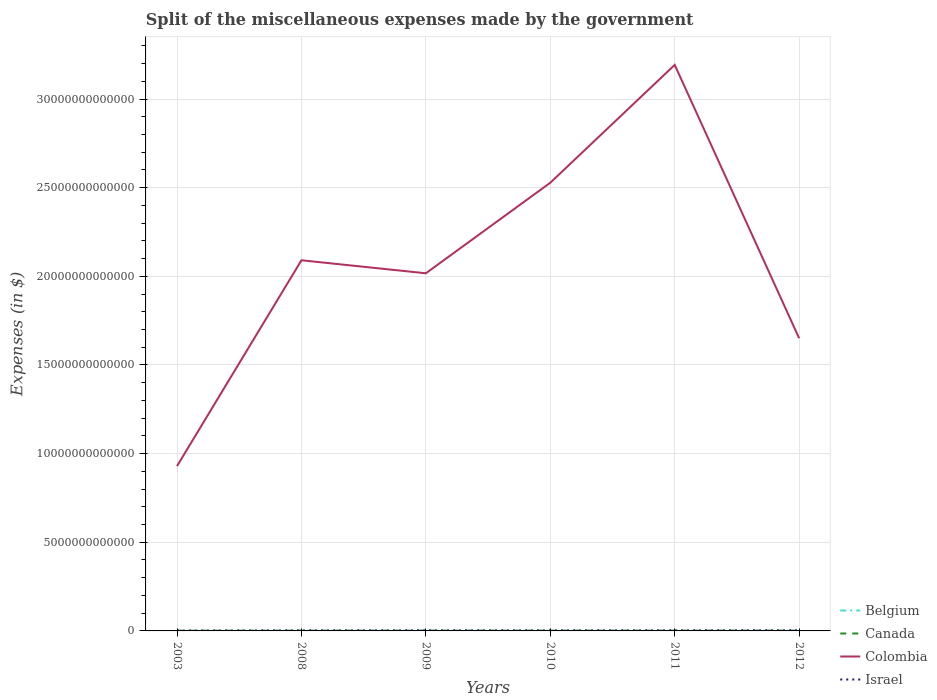How many different coloured lines are there?
Provide a succinct answer. 4. Across all years, what is the maximum miscellaneous expenses made by the government in Colombia?
Make the answer very short. 9.30e+12. What is the total miscellaneous expenses made by the government in Colombia in the graph?
Offer a terse response. -4.37e+12. What is the difference between the highest and the second highest miscellaneous expenses made by the government in Colombia?
Provide a short and direct response. 2.26e+13. What is the difference between two consecutive major ticks on the Y-axis?
Your answer should be compact. 5.00e+12. How are the legend labels stacked?
Make the answer very short. Vertical. What is the title of the graph?
Your answer should be compact. Split of the miscellaneous expenses made by the government. What is the label or title of the X-axis?
Keep it short and to the point. Years. What is the label or title of the Y-axis?
Give a very brief answer. Expenses (in $). What is the Expenses (in $) of Belgium in 2003?
Make the answer very short. 3.96e+09. What is the Expenses (in $) of Canada in 2003?
Provide a succinct answer. 1.14e+1. What is the Expenses (in $) in Colombia in 2003?
Make the answer very short. 9.30e+12. What is the Expenses (in $) in Israel in 2003?
Keep it short and to the point. 1.77e+1. What is the Expenses (in $) of Belgium in 2008?
Provide a short and direct response. 3.34e+09. What is the Expenses (in $) in Canada in 2008?
Your answer should be very brief. 1.42e+1. What is the Expenses (in $) of Colombia in 2008?
Offer a terse response. 2.09e+13. What is the Expenses (in $) in Israel in 2008?
Offer a very short reply. 2.70e+1. What is the Expenses (in $) in Belgium in 2009?
Give a very brief answer. 4.92e+09. What is the Expenses (in $) in Canada in 2009?
Your response must be concise. 1.54e+1. What is the Expenses (in $) of Colombia in 2009?
Give a very brief answer. 2.02e+13. What is the Expenses (in $) of Israel in 2009?
Your answer should be very brief. 2.99e+1. What is the Expenses (in $) in Belgium in 2010?
Your response must be concise. 3.68e+09. What is the Expenses (in $) of Canada in 2010?
Give a very brief answer. 1.59e+1. What is the Expenses (in $) in Colombia in 2010?
Keep it short and to the point. 2.53e+13. What is the Expenses (in $) of Israel in 2010?
Your response must be concise. 2.93e+1. What is the Expenses (in $) in Belgium in 2011?
Offer a very short reply. 7.59e+08. What is the Expenses (in $) in Canada in 2011?
Ensure brevity in your answer.  1.62e+1. What is the Expenses (in $) of Colombia in 2011?
Offer a terse response. 3.19e+13. What is the Expenses (in $) of Israel in 2011?
Your response must be concise. 2.95e+1. What is the Expenses (in $) in Belgium in 2012?
Offer a very short reply. 7.77e+08. What is the Expenses (in $) in Canada in 2012?
Make the answer very short. 1.66e+1. What is the Expenses (in $) in Colombia in 2012?
Your answer should be very brief. 1.65e+13. What is the Expenses (in $) in Israel in 2012?
Make the answer very short. 3.33e+1. Across all years, what is the maximum Expenses (in $) of Belgium?
Your answer should be compact. 4.92e+09. Across all years, what is the maximum Expenses (in $) in Canada?
Offer a very short reply. 1.66e+1. Across all years, what is the maximum Expenses (in $) in Colombia?
Ensure brevity in your answer.  3.19e+13. Across all years, what is the maximum Expenses (in $) of Israel?
Your response must be concise. 3.33e+1. Across all years, what is the minimum Expenses (in $) in Belgium?
Provide a succinct answer. 7.59e+08. Across all years, what is the minimum Expenses (in $) of Canada?
Offer a terse response. 1.14e+1. Across all years, what is the minimum Expenses (in $) in Colombia?
Give a very brief answer. 9.30e+12. Across all years, what is the minimum Expenses (in $) in Israel?
Offer a terse response. 1.77e+1. What is the total Expenses (in $) in Belgium in the graph?
Provide a short and direct response. 1.74e+1. What is the total Expenses (in $) in Canada in the graph?
Make the answer very short. 8.98e+1. What is the total Expenses (in $) of Colombia in the graph?
Make the answer very short. 1.24e+14. What is the total Expenses (in $) in Israel in the graph?
Your response must be concise. 1.67e+11. What is the difference between the Expenses (in $) in Belgium in 2003 and that in 2008?
Offer a terse response. 6.13e+08. What is the difference between the Expenses (in $) of Canada in 2003 and that in 2008?
Make the answer very short. -2.78e+09. What is the difference between the Expenses (in $) of Colombia in 2003 and that in 2008?
Give a very brief answer. -1.16e+13. What is the difference between the Expenses (in $) in Israel in 2003 and that in 2008?
Provide a short and direct response. -9.31e+09. What is the difference between the Expenses (in $) of Belgium in 2003 and that in 2009?
Keep it short and to the point. -9.66e+08. What is the difference between the Expenses (in $) of Canada in 2003 and that in 2009?
Keep it short and to the point. -3.97e+09. What is the difference between the Expenses (in $) of Colombia in 2003 and that in 2009?
Provide a succinct answer. -1.09e+13. What is the difference between the Expenses (in $) of Israel in 2003 and that in 2009?
Provide a succinct answer. -1.22e+1. What is the difference between the Expenses (in $) of Belgium in 2003 and that in 2010?
Your answer should be very brief. 2.74e+08. What is the difference between the Expenses (in $) of Canada in 2003 and that in 2010?
Offer a terse response. -4.48e+09. What is the difference between the Expenses (in $) of Colombia in 2003 and that in 2010?
Keep it short and to the point. -1.60e+13. What is the difference between the Expenses (in $) in Israel in 2003 and that in 2010?
Make the answer very short. -1.16e+1. What is the difference between the Expenses (in $) in Belgium in 2003 and that in 2011?
Provide a short and direct response. 3.20e+09. What is the difference between the Expenses (in $) in Canada in 2003 and that in 2011?
Give a very brief answer. -4.76e+09. What is the difference between the Expenses (in $) in Colombia in 2003 and that in 2011?
Keep it short and to the point. -2.26e+13. What is the difference between the Expenses (in $) of Israel in 2003 and that in 2011?
Make the answer very short. -1.18e+1. What is the difference between the Expenses (in $) of Belgium in 2003 and that in 2012?
Your response must be concise. 3.18e+09. What is the difference between the Expenses (in $) in Canada in 2003 and that in 2012?
Your answer should be compact. -5.13e+09. What is the difference between the Expenses (in $) of Colombia in 2003 and that in 2012?
Offer a terse response. -7.21e+12. What is the difference between the Expenses (in $) in Israel in 2003 and that in 2012?
Make the answer very short. -1.56e+1. What is the difference between the Expenses (in $) in Belgium in 2008 and that in 2009?
Offer a very short reply. -1.58e+09. What is the difference between the Expenses (in $) of Canada in 2008 and that in 2009?
Your response must be concise. -1.19e+09. What is the difference between the Expenses (in $) in Colombia in 2008 and that in 2009?
Your answer should be compact. 7.33e+11. What is the difference between the Expenses (in $) of Israel in 2008 and that in 2009?
Provide a short and direct response. -2.87e+09. What is the difference between the Expenses (in $) of Belgium in 2008 and that in 2010?
Make the answer very short. -3.39e+08. What is the difference between the Expenses (in $) of Canada in 2008 and that in 2010?
Provide a succinct answer. -1.70e+09. What is the difference between the Expenses (in $) in Colombia in 2008 and that in 2010?
Ensure brevity in your answer.  -4.37e+12. What is the difference between the Expenses (in $) of Israel in 2008 and that in 2010?
Your answer should be very brief. -2.29e+09. What is the difference between the Expenses (in $) of Belgium in 2008 and that in 2011?
Make the answer very short. 2.58e+09. What is the difference between the Expenses (in $) of Canada in 2008 and that in 2011?
Your answer should be very brief. -1.98e+09. What is the difference between the Expenses (in $) in Colombia in 2008 and that in 2011?
Your answer should be compact. -1.10e+13. What is the difference between the Expenses (in $) of Israel in 2008 and that in 2011?
Provide a short and direct response. -2.46e+09. What is the difference between the Expenses (in $) of Belgium in 2008 and that in 2012?
Offer a terse response. 2.57e+09. What is the difference between the Expenses (in $) in Canada in 2008 and that in 2012?
Provide a short and direct response. -2.35e+09. What is the difference between the Expenses (in $) in Colombia in 2008 and that in 2012?
Offer a terse response. 4.40e+12. What is the difference between the Expenses (in $) in Israel in 2008 and that in 2012?
Provide a short and direct response. -6.25e+09. What is the difference between the Expenses (in $) in Belgium in 2009 and that in 2010?
Ensure brevity in your answer.  1.24e+09. What is the difference between the Expenses (in $) in Canada in 2009 and that in 2010?
Give a very brief answer. -5.11e+08. What is the difference between the Expenses (in $) of Colombia in 2009 and that in 2010?
Provide a short and direct response. -5.11e+12. What is the difference between the Expenses (in $) in Israel in 2009 and that in 2010?
Your answer should be compact. 5.78e+08. What is the difference between the Expenses (in $) of Belgium in 2009 and that in 2011?
Give a very brief answer. 4.16e+09. What is the difference between the Expenses (in $) of Canada in 2009 and that in 2011?
Your response must be concise. -7.90e+08. What is the difference between the Expenses (in $) of Colombia in 2009 and that in 2011?
Offer a terse response. -1.18e+13. What is the difference between the Expenses (in $) of Israel in 2009 and that in 2011?
Keep it short and to the point. 4.09e+08. What is the difference between the Expenses (in $) in Belgium in 2009 and that in 2012?
Provide a succinct answer. 4.15e+09. What is the difference between the Expenses (in $) of Canada in 2009 and that in 2012?
Offer a very short reply. -1.16e+09. What is the difference between the Expenses (in $) of Colombia in 2009 and that in 2012?
Provide a succinct answer. 3.66e+12. What is the difference between the Expenses (in $) of Israel in 2009 and that in 2012?
Your answer should be very brief. -3.37e+09. What is the difference between the Expenses (in $) in Belgium in 2010 and that in 2011?
Offer a very short reply. 2.92e+09. What is the difference between the Expenses (in $) in Canada in 2010 and that in 2011?
Give a very brief answer. -2.79e+08. What is the difference between the Expenses (in $) of Colombia in 2010 and that in 2011?
Your answer should be very brief. -6.65e+12. What is the difference between the Expenses (in $) in Israel in 2010 and that in 2011?
Provide a short and direct response. -1.70e+08. What is the difference between the Expenses (in $) in Belgium in 2010 and that in 2012?
Offer a terse response. 2.91e+09. What is the difference between the Expenses (in $) of Canada in 2010 and that in 2012?
Give a very brief answer. -6.46e+08. What is the difference between the Expenses (in $) in Colombia in 2010 and that in 2012?
Your answer should be compact. 8.77e+12. What is the difference between the Expenses (in $) in Israel in 2010 and that in 2012?
Give a very brief answer. -3.95e+09. What is the difference between the Expenses (in $) of Belgium in 2011 and that in 2012?
Give a very brief answer. -1.77e+07. What is the difference between the Expenses (in $) of Canada in 2011 and that in 2012?
Provide a succinct answer. -3.67e+08. What is the difference between the Expenses (in $) in Colombia in 2011 and that in 2012?
Give a very brief answer. 1.54e+13. What is the difference between the Expenses (in $) of Israel in 2011 and that in 2012?
Give a very brief answer. -3.78e+09. What is the difference between the Expenses (in $) in Belgium in 2003 and the Expenses (in $) in Canada in 2008?
Give a very brief answer. -1.03e+1. What is the difference between the Expenses (in $) of Belgium in 2003 and the Expenses (in $) of Colombia in 2008?
Your answer should be compact. -2.09e+13. What is the difference between the Expenses (in $) of Belgium in 2003 and the Expenses (in $) of Israel in 2008?
Provide a succinct answer. -2.31e+1. What is the difference between the Expenses (in $) in Canada in 2003 and the Expenses (in $) in Colombia in 2008?
Your answer should be very brief. -2.09e+13. What is the difference between the Expenses (in $) in Canada in 2003 and the Expenses (in $) in Israel in 2008?
Your answer should be compact. -1.56e+1. What is the difference between the Expenses (in $) of Colombia in 2003 and the Expenses (in $) of Israel in 2008?
Your answer should be compact. 9.27e+12. What is the difference between the Expenses (in $) of Belgium in 2003 and the Expenses (in $) of Canada in 2009?
Your response must be concise. -1.15e+1. What is the difference between the Expenses (in $) in Belgium in 2003 and the Expenses (in $) in Colombia in 2009?
Ensure brevity in your answer.  -2.02e+13. What is the difference between the Expenses (in $) of Belgium in 2003 and the Expenses (in $) of Israel in 2009?
Keep it short and to the point. -2.59e+1. What is the difference between the Expenses (in $) in Canada in 2003 and the Expenses (in $) in Colombia in 2009?
Offer a very short reply. -2.02e+13. What is the difference between the Expenses (in $) in Canada in 2003 and the Expenses (in $) in Israel in 2009?
Ensure brevity in your answer.  -1.84e+1. What is the difference between the Expenses (in $) in Colombia in 2003 and the Expenses (in $) in Israel in 2009?
Offer a terse response. 9.27e+12. What is the difference between the Expenses (in $) in Belgium in 2003 and the Expenses (in $) in Canada in 2010?
Your answer should be compact. -1.20e+1. What is the difference between the Expenses (in $) in Belgium in 2003 and the Expenses (in $) in Colombia in 2010?
Keep it short and to the point. -2.53e+13. What is the difference between the Expenses (in $) of Belgium in 2003 and the Expenses (in $) of Israel in 2010?
Provide a succinct answer. -2.54e+1. What is the difference between the Expenses (in $) in Canada in 2003 and the Expenses (in $) in Colombia in 2010?
Keep it short and to the point. -2.53e+13. What is the difference between the Expenses (in $) of Canada in 2003 and the Expenses (in $) of Israel in 2010?
Provide a succinct answer. -1.79e+1. What is the difference between the Expenses (in $) of Colombia in 2003 and the Expenses (in $) of Israel in 2010?
Provide a succinct answer. 9.27e+12. What is the difference between the Expenses (in $) in Belgium in 2003 and the Expenses (in $) in Canada in 2011?
Your response must be concise. -1.22e+1. What is the difference between the Expenses (in $) of Belgium in 2003 and the Expenses (in $) of Colombia in 2011?
Ensure brevity in your answer.  -3.19e+13. What is the difference between the Expenses (in $) of Belgium in 2003 and the Expenses (in $) of Israel in 2011?
Ensure brevity in your answer.  -2.55e+1. What is the difference between the Expenses (in $) of Canada in 2003 and the Expenses (in $) of Colombia in 2011?
Your answer should be very brief. -3.19e+13. What is the difference between the Expenses (in $) of Canada in 2003 and the Expenses (in $) of Israel in 2011?
Keep it short and to the point. -1.80e+1. What is the difference between the Expenses (in $) in Colombia in 2003 and the Expenses (in $) in Israel in 2011?
Give a very brief answer. 9.27e+12. What is the difference between the Expenses (in $) in Belgium in 2003 and the Expenses (in $) in Canada in 2012?
Give a very brief answer. -1.26e+1. What is the difference between the Expenses (in $) in Belgium in 2003 and the Expenses (in $) in Colombia in 2012?
Offer a terse response. -1.65e+13. What is the difference between the Expenses (in $) in Belgium in 2003 and the Expenses (in $) in Israel in 2012?
Offer a terse response. -2.93e+1. What is the difference between the Expenses (in $) in Canada in 2003 and the Expenses (in $) in Colombia in 2012?
Make the answer very short. -1.65e+13. What is the difference between the Expenses (in $) of Canada in 2003 and the Expenses (in $) of Israel in 2012?
Keep it short and to the point. -2.18e+1. What is the difference between the Expenses (in $) in Colombia in 2003 and the Expenses (in $) in Israel in 2012?
Keep it short and to the point. 9.26e+12. What is the difference between the Expenses (in $) of Belgium in 2008 and the Expenses (in $) of Canada in 2009?
Provide a succinct answer. -1.21e+1. What is the difference between the Expenses (in $) of Belgium in 2008 and the Expenses (in $) of Colombia in 2009?
Keep it short and to the point. -2.02e+13. What is the difference between the Expenses (in $) in Belgium in 2008 and the Expenses (in $) in Israel in 2009?
Your answer should be very brief. -2.65e+1. What is the difference between the Expenses (in $) of Canada in 2008 and the Expenses (in $) of Colombia in 2009?
Make the answer very short. -2.02e+13. What is the difference between the Expenses (in $) of Canada in 2008 and the Expenses (in $) of Israel in 2009?
Provide a short and direct response. -1.57e+1. What is the difference between the Expenses (in $) of Colombia in 2008 and the Expenses (in $) of Israel in 2009?
Your answer should be compact. 2.09e+13. What is the difference between the Expenses (in $) of Belgium in 2008 and the Expenses (in $) of Canada in 2010?
Make the answer very short. -1.26e+1. What is the difference between the Expenses (in $) in Belgium in 2008 and the Expenses (in $) in Colombia in 2010?
Make the answer very short. -2.53e+13. What is the difference between the Expenses (in $) of Belgium in 2008 and the Expenses (in $) of Israel in 2010?
Ensure brevity in your answer.  -2.60e+1. What is the difference between the Expenses (in $) of Canada in 2008 and the Expenses (in $) of Colombia in 2010?
Provide a short and direct response. -2.53e+13. What is the difference between the Expenses (in $) in Canada in 2008 and the Expenses (in $) in Israel in 2010?
Keep it short and to the point. -1.51e+1. What is the difference between the Expenses (in $) of Colombia in 2008 and the Expenses (in $) of Israel in 2010?
Offer a terse response. 2.09e+13. What is the difference between the Expenses (in $) of Belgium in 2008 and the Expenses (in $) of Canada in 2011?
Your response must be concise. -1.29e+1. What is the difference between the Expenses (in $) in Belgium in 2008 and the Expenses (in $) in Colombia in 2011?
Your answer should be very brief. -3.19e+13. What is the difference between the Expenses (in $) of Belgium in 2008 and the Expenses (in $) of Israel in 2011?
Provide a succinct answer. -2.61e+1. What is the difference between the Expenses (in $) of Canada in 2008 and the Expenses (in $) of Colombia in 2011?
Provide a short and direct response. -3.19e+13. What is the difference between the Expenses (in $) of Canada in 2008 and the Expenses (in $) of Israel in 2011?
Keep it short and to the point. -1.53e+1. What is the difference between the Expenses (in $) in Colombia in 2008 and the Expenses (in $) in Israel in 2011?
Keep it short and to the point. 2.09e+13. What is the difference between the Expenses (in $) of Belgium in 2008 and the Expenses (in $) of Canada in 2012?
Provide a succinct answer. -1.32e+1. What is the difference between the Expenses (in $) in Belgium in 2008 and the Expenses (in $) in Colombia in 2012?
Give a very brief answer. -1.65e+13. What is the difference between the Expenses (in $) in Belgium in 2008 and the Expenses (in $) in Israel in 2012?
Keep it short and to the point. -2.99e+1. What is the difference between the Expenses (in $) of Canada in 2008 and the Expenses (in $) of Colombia in 2012?
Keep it short and to the point. -1.65e+13. What is the difference between the Expenses (in $) in Canada in 2008 and the Expenses (in $) in Israel in 2012?
Keep it short and to the point. -1.90e+1. What is the difference between the Expenses (in $) in Colombia in 2008 and the Expenses (in $) in Israel in 2012?
Your response must be concise. 2.09e+13. What is the difference between the Expenses (in $) in Belgium in 2009 and the Expenses (in $) in Canada in 2010?
Your answer should be compact. -1.10e+1. What is the difference between the Expenses (in $) in Belgium in 2009 and the Expenses (in $) in Colombia in 2010?
Offer a very short reply. -2.53e+13. What is the difference between the Expenses (in $) of Belgium in 2009 and the Expenses (in $) of Israel in 2010?
Ensure brevity in your answer.  -2.44e+1. What is the difference between the Expenses (in $) in Canada in 2009 and the Expenses (in $) in Colombia in 2010?
Your answer should be very brief. -2.53e+13. What is the difference between the Expenses (in $) in Canada in 2009 and the Expenses (in $) in Israel in 2010?
Provide a succinct answer. -1.39e+1. What is the difference between the Expenses (in $) in Colombia in 2009 and the Expenses (in $) in Israel in 2010?
Your answer should be compact. 2.01e+13. What is the difference between the Expenses (in $) in Belgium in 2009 and the Expenses (in $) in Canada in 2011?
Keep it short and to the point. -1.13e+1. What is the difference between the Expenses (in $) in Belgium in 2009 and the Expenses (in $) in Colombia in 2011?
Your response must be concise. -3.19e+13. What is the difference between the Expenses (in $) of Belgium in 2009 and the Expenses (in $) of Israel in 2011?
Ensure brevity in your answer.  -2.46e+1. What is the difference between the Expenses (in $) in Canada in 2009 and the Expenses (in $) in Colombia in 2011?
Keep it short and to the point. -3.19e+13. What is the difference between the Expenses (in $) of Canada in 2009 and the Expenses (in $) of Israel in 2011?
Offer a terse response. -1.41e+1. What is the difference between the Expenses (in $) in Colombia in 2009 and the Expenses (in $) in Israel in 2011?
Give a very brief answer. 2.01e+13. What is the difference between the Expenses (in $) of Belgium in 2009 and the Expenses (in $) of Canada in 2012?
Give a very brief answer. -1.16e+1. What is the difference between the Expenses (in $) in Belgium in 2009 and the Expenses (in $) in Colombia in 2012?
Keep it short and to the point. -1.65e+13. What is the difference between the Expenses (in $) of Belgium in 2009 and the Expenses (in $) of Israel in 2012?
Offer a very short reply. -2.83e+1. What is the difference between the Expenses (in $) in Canada in 2009 and the Expenses (in $) in Colombia in 2012?
Give a very brief answer. -1.65e+13. What is the difference between the Expenses (in $) in Canada in 2009 and the Expenses (in $) in Israel in 2012?
Your answer should be compact. -1.78e+1. What is the difference between the Expenses (in $) of Colombia in 2009 and the Expenses (in $) of Israel in 2012?
Ensure brevity in your answer.  2.01e+13. What is the difference between the Expenses (in $) of Belgium in 2010 and the Expenses (in $) of Canada in 2011?
Your answer should be very brief. -1.25e+1. What is the difference between the Expenses (in $) of Belgium in 2010 and the Expenses (in $) of Colombia in 2011?
Make the answer very short. -3.19e+13. What is the difference between the Expenses (in $) of Belgium in 2010 and the Expenses (in $) of Israel in 2011?
Your response must be concise. -2.58e+1. What is the difference between the Expenses (in $) in Canada in 2010 and the Expenses (in $) in Colombia in 2011?
Offer a terse response. -3.19e+13. What is the difference between the Expenses (in $) in Canada in 2010 and the Expenses (in $) in Israel in 2011?
Provide a short and direct response. -1.36e+1. What is the difference between the Expenses (in $) of Colombia in 2010 and the Expenses (in $) of Israel in 2011?
Keep it short and to the point. 2.52e+13. What is the difference between the Expenses (in $) of Belgium in 2010 and the Expenses (in $) of Canada in 2012?
Your answer should be very brief. -1.29e+1. What is the difference between the Expenses (in $) in Belgium in 2010 and the Expenses (in $) in Colombia in 2012?
Offer a very short reply. -1.65e+13. What is the difference between the Expenses (in $) of Belgium in 2010 and the Expenses (in $) of Israel in 2012?
Provide a short and direct response. -2.96e+1. What is the difference between the Expenses (in $) of Canada in 2010 and the Expenses (in $) of Colombia in 2012?
Offer a terse response. -1.65e+13. What is the difference between the Expenses (in $) of Canada in 2010 and the Expenses (in $) of Israel in 2012?
Keep it short and to the point. -1.73e+1. What is the difference between the Expenses (in $) of Colombia in 2010 and the Expenses (in $) of Israel in 2012?
Give a very brief answer. 2.52e+13. What is the difference between the Expenses (in $) of Belgium in 2011 and the Expenses (in $) of Canada in 2012?
Give a very brief answer. -1.58e+1. What is the difference between the Expenses (in $) of Belgium in 2011 and the Expenses (in $) of Colombia in 2012?
Give a very brief answer. -1.65e+13. What is the difference between the Expenses (in $) in Belgium in 2011 and the Expenses (in $) in Israel in 2012?
Your answer should be compact. -3.25e+1. What is the difference between the Expenses (in $) in Canada in 2011 and the Expenses (in $) in Colombia in 2012?
Keep it short and to the point. -1.65e+13. What is the difference between the Expenses (in $) in Canada in 2011 and the Expenses (in $) in Israel in 2012?
Ensure brevity in your answer.  -1.71e+1. What is the difference between the Expenses (in $) of Colombia in 2011 and the Expenses (in $) of Israel in 2012?
Keep it short and to the point. 3.19e+13. What is the average Expenses (in $) of Belgium per year?
Ensure brevity in your answer.  2.91e+09. What is the average Expenses (in $) of Canada per year?
Your answer should be compact. 1.50e+1. What is the average Expenses (in $) of Colombia per year?
Offer a very short reply. 2.07e+13. What is the average Expenses (in $) in Israel per year?
Offer a terse response. 2.78e+1. In the year 2003, what is the difference between the Expenses (in $) in Belgium and Expenses (in $) in Canada?
Offer a very short reply. -7.49e+09. In the year 2003, what is the difference between the Expenses (in $) in Belgium and Expenses (in $) in Colombia?
Make the answer very short. -9.29e+12. In the year 2003, what is the difference between the Expenses (in $) in Belgium and Expenses (in $) in Israel?
Give a very brief answer. -1.38e+1. In the year 2003, what is the difference between the Expenses (in $) in Canada and Expenses (in $) in Colombia?
Provide a short and direct response. -9.28e+12. In the year 2003, what is the difference between the Expenses (in $) of Canada and Expenses (in $) of Israel?
Make the answer very short. -6.27e+09. In the year 2003, what is the difference between the Expenses (in $) in Colombia and Expenses (in $) in Israel?
Keep it short and to the point. 9.28e+12. In the year 2008, what is the difference between the Expenses (in $) of Belgium and Expenses (in $) of Canada?
Give a very brief answer. -1.09e+1. In the year 2008, what is the difference between the Expenses (in $) of Belgium and Expenses (in $) of Colombia?
Your answer should be compact. -2.09e+13. In the year 2008, what is the difference between the Expenses (in $) of Belgium and Expenses (in $) of Israel?
Provide a short and direct response. -2.37e+1. In the year 2008, what is the difference between the Expenses (in $) in Canada and Expenses (in $) in Colombia?
Make the answer very short. -2.09e+13. In the year 2008, what is the difference between the Expenses (in $) of Canada and Expenses (in $) of Israel?
Offer a terse response. -1.28e+1. In the year 2008, what is the difference between the Expenses (in $) in Colombia and Expenses (in $) in Israel?
Make the answer very short. 2.09e+13. In the year 2009, what is the difference between the Expenses (in $) of Belgium and Expenses (in $) of Canada?
Give a very brief answer. -1.05e+1. In the year 2009, what is the difference between the Expenses (in $) in Belgium and Expenses (in $) in Colombia?
Your answer should be compact. -2.02e+13. In the year 2009, what is the difference between the Expenses (in $) in Belgium and Expenses (in $) in Israel?
Keep it short and to the point. -2.50e+1. In the year 2009, what is the difference between the Expenses (in $) of Canada and Expenses (in $) of Colombia?
Give a very brief answer. -2.02e+13. In the year 2009, what is the difference between the Expenses (in $) of Canada and Expenses (in $) of Israel?
Provide a short and direct response. -1.45e+1. In the year 2009, what is the difference between the Expenses (in $) of Colombia and Expenses (in $) of Israel?
Offer a terse response. 2.01e+13. In the year 2010, what is the difference between the Expenses (in $) of Belgium and Expenses (in $) of Canada?
Provide a succinct answer. -1.22e+1. In the year 2010, what is the difference between the Expenses (in $) of Belgium and Expenses (in $) of Colombia?
Ensure brevity in your answer.  -2.53e+13. In the year 2010, what is the difference between the Expenses (in $) of Belgium and Expenses (in $) of Israel?
Keep it short and to the point. -2.56e+1. In the year 2010, what is the difference between the Expenses (in $) of Canada and Expenses (in $) of Colombia?
Your answer should be very brief. -2.53e+13. In the year 2010, what is the difference between the Expenses (in $) in Canada and Expenses (in $) in Israel?
Offer a terse response. -1.34e+1. In the year 2010, what is the difference between the Expenses (in $) of Colombia and Expenses (in $) of Israel?
Provide a short and direct response. 2.52e+13. In the year 2011, what is the difference between the Expenses (in $) in Belgium and Expenses (in $) in Canada?
Ensure brevity in your answer.  -1.54e+1. In the year 2011, what is the difference between the Expenses (in $) of Belgium and Expenses (in $) of Colombia?
Make the answer very short. -3.19e+13. In the year 2011, what is the difference between the Expenses (in $) in Belgium and Expenses (in $) in Israel?
Your response must be concise. -2.87e+1. In the year 2011, what is the difference between the Expenses (in $) in Canada and Expenses (in $) in Colombia?
Provide a short and direct response. -3.19e+13. In the year 2011, what is the difference between the Expenses (in $) in Canada and Expenses (in $) in Israel?
Your response must be concise. -1.33e+1. In the year 2011, what is the difference between the Expenses (in $) in Colombia and Expenses (in $) in Israel?
Ensure brevity in your answer.  3.19e+13. In the year 2012, what is the difference between the Expenses (in $) of Belgium and Expenses (in $) of Canada?
Offer a terse response. -1.58e+1. In the year 2012, what is the difference between the Expenses (in $) of Belgium and Expenses (in $) of Colombia?
Ensure brevity in your answer.  -1.65e+13. In the year 2012, what is the difference between the Expenses (in $) of Belgium and Expenses (in $) of Israel?
Your answer should be compact. -3.25e+1. In the year 2012, what is the difference between the Expenses (in $) of Canada and Expenses (in $) of Colombia?
Give a very brief answer. -1.65e+13. In the year 2012, what is the difference between the Expenses (in $) of Canada and Expenses (in $) of Israel?
Your answer should be compact. -1.67e+1. In the year 2012, what is the difference between the Expenses (in $) of Colombia and Expenses (in $) of Israel?
Provide a short and direct response. 1.65e+13. What is the ratio of the Expenses (in $) in Belgium in 2003 to that in 2008?
Provide a short and direct response. 1.18. What is the ratio of the Expenses (in $) in Canada in 2003 to that in 2008?
Make the answer very short. 0.8. What is the ratio of the Expenses (in $) of Colombia in 2003 to that in 2008?
Your response must be concise. 0.44. What is the ratio of the Expenses (in $) in Israel in 2003 to that in 2008?
Your response must be concise. 0.66. What is the ratio of the Expenses (in $) in Belgium in 2003 to that in 2009?
Your response must be concise. 0.8. What is the ratio of the Expenses (in $) of Canada in 2003 to that in 2009?
Make the answer very short. 0.74. What is the ratio of the Expenses (in $) of Colombia in 2003 to that in 2009?
Give a very brief answer. 0.46. What is the ratio of the Expenses (in $) of Israel in 2003 to that in 2009?
Your answer should be compact. 0.59. What is the ratio of the Expenses (in $) of Belgium in 2003 to that in 2010?
Your answer should be very brief. 1.07. What is the ratio of the Expenses (in $) of Canada in 2003 to that in 2010?
Your answer should be very brief. 0.72. What is the ratio of the Expenses (in $) of Colombia in 2003 to that in 2010?
Your response must be concise. 0.37. What is the ratio of the Expenses (in $) of Israel in 2003 to that in 2010?
Give a very brief answer. 0.6. What is the ratio of the Expenses (in $) in Belgium in 2003 to that in 2011?
Make the answer very short. 5.21. What is the ratio of the Expenses (in $) in Canada in 2003 to that in 2011?
Your answer should be very brief. 0.71. What is the ratio of the Expenses (in $) in Colombia in 2003 to that in 2011?
Offer a very short reply. 0.29. What is the ratio of the Expenses (in $) of Israel in 2003 to that in 2011?
Ensure brevity in your answer.  0.6. What is the ratio of the Expenses (in $) in Belgium in 2003 to that in 2012?
Provide a short and direct response. 5.09. What is the ratio of the Expenses (in $) of Canada in 2003 to that in 2012?
Your response must be concise. 0.69. What is the ratio of the Expenses (in $) of Colombia in 2003 to that in 2012?
Your answer should be compact. 0.56. What is the ratio of the Expenses (in $) of Israel in 2003 to that in 2012?
Offer a terse response. 0.53. What is the ratio of the Expenses (in $) in Belgium in 2008 to that in 2009?
Give a very brief answer. 0.68. What is the ratio of the Expenses (in $) in Canada in 2008 to that in 2009?
Provide a short and direct response. 0.92. What is the ratio of the Expenses (in $) of Colombia in 2008 to that in 2009?
Give a very brief answer. 1.04. What is the ratio of the Expenses (in $) in Israel in 2008 to that in 2009?
Offer a terse response. 0.9. What is the ratio of the Expenses (in $) of Belgium in 2008 to that in 2010?
Your answer should be compact. 0.91. What is the ratio of the Expenses (in $) of Canada in 2008 to that in 2010?
Keep it short and to the point. 0.89. What is the ratio of the Expenses (in $) of Colombia in 2008 to that in 2010?
Your answer should be compact. 0.83. What is the ratio of the Expenses (in $) in Israel in 2008 to that in 2010?
Ensure brevity in your answer.  0.92. What is the ratio of the Expenses (in $) of Belgium in 2008 to that in 2011?
Provide a short and direct response. 4.4. What is the ratio of the Expenses (in $) in Canada in 2008 to that in 2011?
Offer a terse response. 0.88. What is the ratio of the Expenses (in $) in Colombia in 2008 to that in 2011?
Give a very brief answer. 0.65. What is the ratio of the Expenses (in $) in Israel in 2008 to that in 2011?
Your answer should be very brief. 0.92. What is the ratio of the Expenses (in $) in Belgium in 2008 to that in 2012?
Your response must be concise. 4.3. What is the ratio of the Expenses (in $) of Canada in 2008 to that in 2012?
Provide a succinct answer. 0.86. What is the ratio of the Expenses (in $) in Colombia in 2008 to that in 2012?
Your response must be concise. 1.27. What is the ratio of the Expenses (in $) of Israel in 2008 to that in 2012?
Offer a very short reply. 0.81. What is the ratio of the Expenses (in $) in Belgium in 2009 to that in 2010?
Ensure brevity in your answer.  1.34. What is the ratio of the Expenses (in $) in Canada in 2009 to that in 2010?
Ensure brevity in your answer.  0.97. What is the ratio of the Expenses (in $) of Colombia in 2009 to that in 2010?
Your answer should be compact. 0.8. What is the ratio of the Expenses (in $) in Israel in 2009 to that in 2010?
Make the answer very short. 1.02. What is the ratio of the Expenses (in $) in Belgium in 2009 to that in 2011?
Offer a terse response. 6.48. What is the ratio of the Expenses (in $) of Canada in 2009 to that in 2011?
Offer a very short reply. 0.95. What is the ratio of the Expenses (in $) in Colombia in 2009 to that in 2011?
Your answer should be compact. 0.63. What is the ratio of the Expenses (in $) in Israel in 2009 to that in 2011?
Keep it short and to the point. 1.01. What is the ratio of the Expenses (in $) of Belgium in 2009 to that in 2012?
Your answer should be very brief. 6.34. What is the ratio of the Expenses (in $) of Canada in 2009 to that in 2012?
Provide a succinct answer. 0.93. What is the ratio of the Expenses (in $) of Colombia in 2009 to that in 2012?
Provide a short and direct response. 1.22. What is the ratio of the Expenses (in $) of Israel in 2009 to that in 2012?
Make the answer very short. 0.9. What is the ratio of the Expenses (in $) of Belgium in 2010 to that in 2011?
Make the answer very short. 4.85. What is the ratio of the Expenses (in $) of Canada in 2010 to that in 2011?
Your answer should be compact. 0.98. What is the ratio of the Expenses (in $) of Colombia in 2010 to that in 2011?
Keep it short and to the point. 0.79. What is the ratio of the Expenses (in $) of Israel in 2010 to that in 2011?
Your response must be concise. 0.99. What is the ratio of the Expenses (in $) of Belgium in 2010 to that in 2012?
Ensure brevity in your answer.  4.74. What is the ratio of the Expenses (in $) in Canada in 2010 to that in 2012?
Offer a terse response. 0.96. What is the ratio of the Expenses (in $) in Colombia in 2010 to that in 2012?
Offer a terse response. 1.53. What is the ratio of the Expenses (in $) of Israel in 2010 to that in 2012?
Offer a very short reply. 0.88. What is the ratio of the Expenses (in $) of Belgium in 2011 to that in 2012?
Keep it short and to the point. 0.98. What is the ratio of the Expenses (in $) in Canada in 2011 to that in 2012?
Provide a succinct answer. 0.98. What is the ratio of the Expenses (in $) of Colombia in 2011 to that in 2012?
Provide a short and direct response. 1.93. What is the ratio of the Expenses (in $) of Israel in 2011 to that in 2012?
Give a very brief answer. 0.89. What is the difference between the highest and the second highest Expenses (in $) of Belgium?
Keep it short and to the point. 9.66e+08. What is the difference between the highest and the second highest Expenses (in $) in Canada?
Your response must be concise. 3.67e+08. What is the difference between the highest and the second highest Expenses (in $) in Colombia?
Your answer should be very brief. 6.65e+12. What is the difference between the highest and the second highest Expenses (in $) in Israel?
Give a very brief answer. 3.37e+09. What is the difference between the highest and the lowest Expenses (in $) in Belgium?
Your answer should be very brief. 4.16e+09. What is the difference between the highest and the lowest Expenses (in $) of Canada?
Offer a very short reply. 5.13e+09. What is the difference between the highest and the lowest Expenses (in $) of Colombia?
Your answer should be very brief. 2.26e+13. What is the difference between the highest and the lowest Expenses (in $) of Israel?
Give a very brief answer. 1.56e+1. 